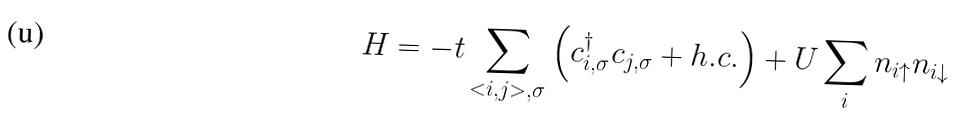Convert formula to latex. <formula><loc_0><loc_0><loc_500><loc_500>H = - t \sum _ { < i , j > , \sigma } \left ( c ^ { \dagger } _ { i , \sigma } c _ { j , \sigma } + h . c . \right ) + U \sum _ { i } n _ { i \uparrow } n _ { i \downarrow }</formula> 